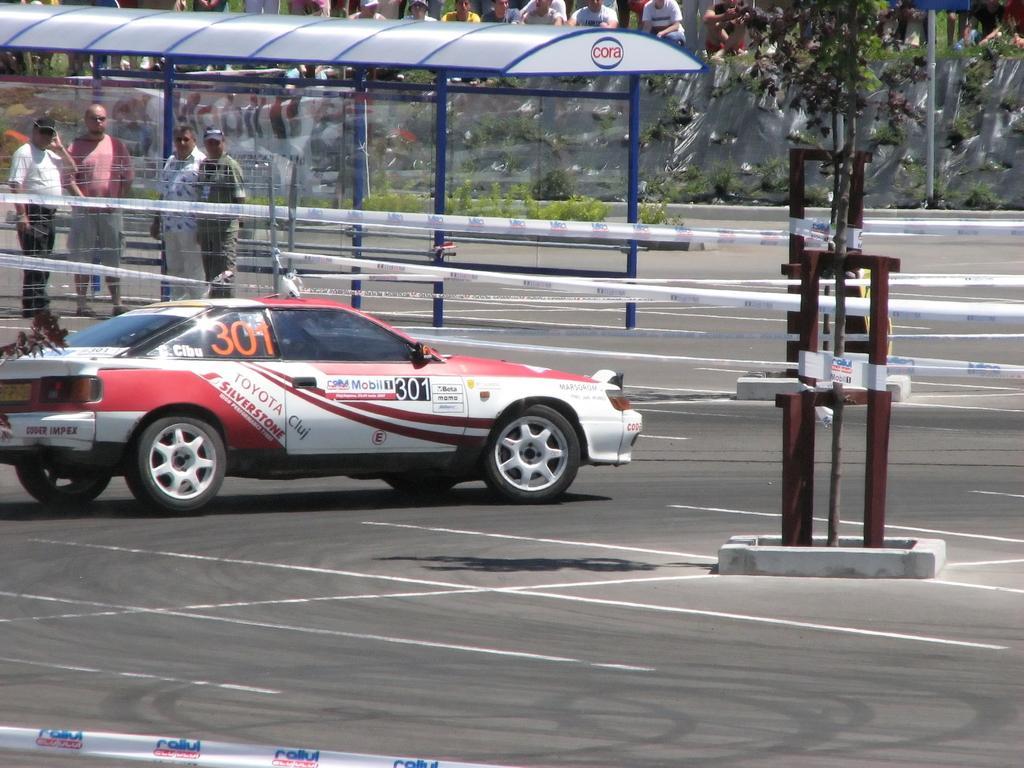Can you describe this image briefly? This image is taken outdoors. At the bottom of the image there is a road. In the background there are a few people. There are few plants. There is a banner with a text on it. On the left side of the image there is a shed. There are many iron bars. Four men are standing on the road. There are few ribbons. A car is parked on the road. On the right side of the image there is a metal object. 